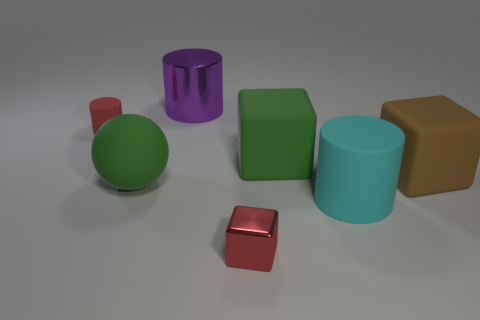Subtract all small red rubber cylinders. How many cylinders are left? 2 Subtract 1 cylinders. How many cylinders are left? 2 Subtract all green cubes. How many cubes are left? 2 Add 1 big blue matte objects. How many objects exist? 8 Subtract 0 green cylinders. How many objects are left? 7 Subtract all balls. How many objects are left? 6 Subtract all brown spheres. Subtract all green cylinders. How many spheres are left? 1 Subtract all small yellow matte spheres. Subtract all big brown blocks. How many objects are left? 6 Add 5 big green objects. How many big green objects are left? 7 Add 4 small gray matte cylinders. How many small gray matte cylinders exist? 4 